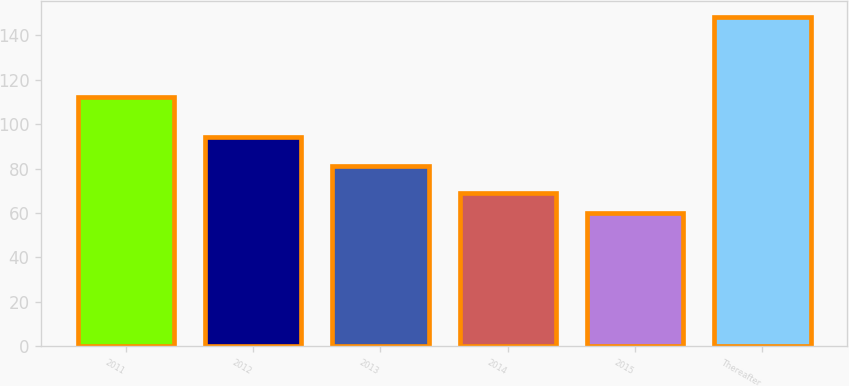Convert chart to OTSL. <chart><loc_0><loc_0><loc_500><loc_500><bar_chart><fcel>2011<fcel>2012<fcel>2013<fcel>2014<fcel>2015<fcel>Thereafter<nl><fcel>112<fcel>94<fcel>81<fcel>68.8<fcel>60<fcel>148<nl></chart> 